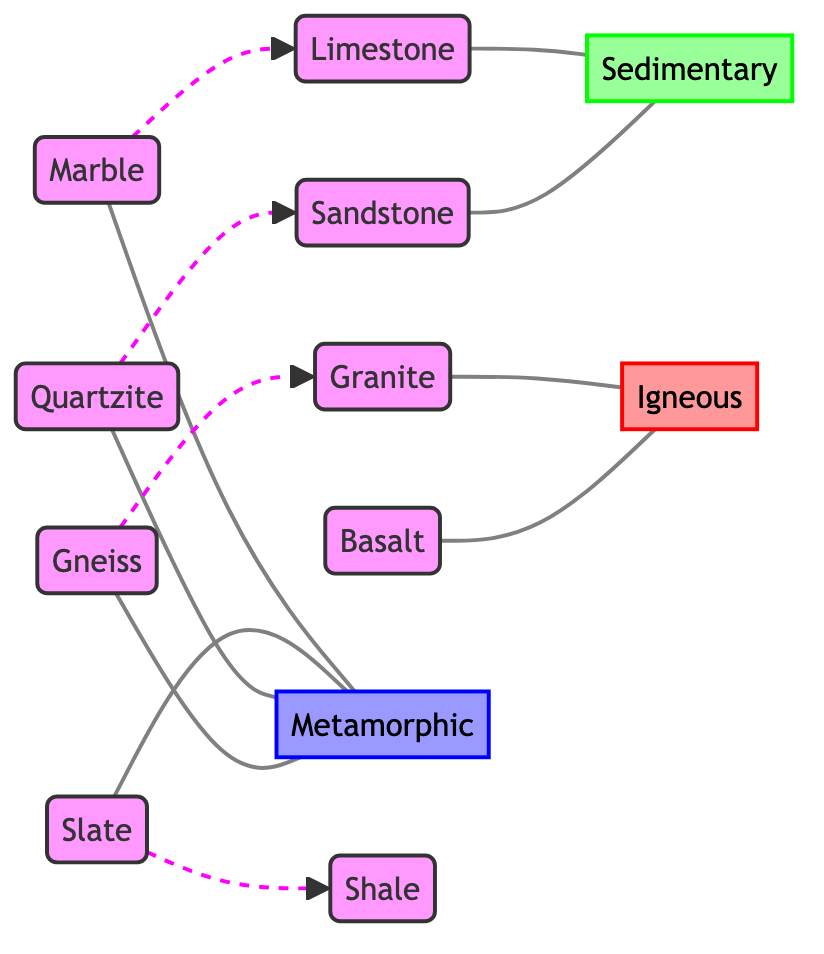What type of rock is granite? According to the diagram, granite is connected to the node labeled "igneous," indicating that it is a type of igneous rock.
Answer: igneous How many metamorphic rocks are represented in the diagram? The diagram lists four rocks that fall under the metamorphic category: marble, slate, quartzite, and gneiss. By counting these nodes, I confirm there are four metamorphic rocks.
Answer: 4 Which rock transforms from limestone? The diagram has a dashed edge connecting marble to limestone, denoting that marble transforms from limestone.
Answer: marble What is the geological origin of sandstone? Sandstone is connected to the node labeled "sedimentary," which signifies that it is classified as a sedimentary rock.
Answer: sedimentary Which rock type is connected to gneiss? The diagram shows that gneiss is connected to the metamorphic node, indicating that it is a metamorphic rock.
Answer: metamorphic How many edges connect the sedimentary rocks? The diagram indicates that there are two sedimentary rocks: limestone and sandstone. Each rock is connected to the sedimentary node by edges, resulting in a total of two edges connecting them.
Answer: 2 Which two rocks are directly classified as igneous? The edges show that granite and basalt are both directly connected to the igneous node, classifying them as igneous rocks.
Answer: granite, basalt What type of rock does slate transform from? Slate is shown to transform from shale as represented by the dashed edge connecting slate to shale.
Answer: shale 